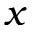Convert formula to latex. <formula><loc_0><loc_0><loc_500><loc_500>x</formula> 